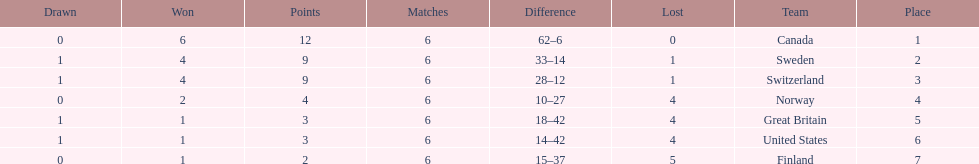What team placed next after sweden? Switzerland. 